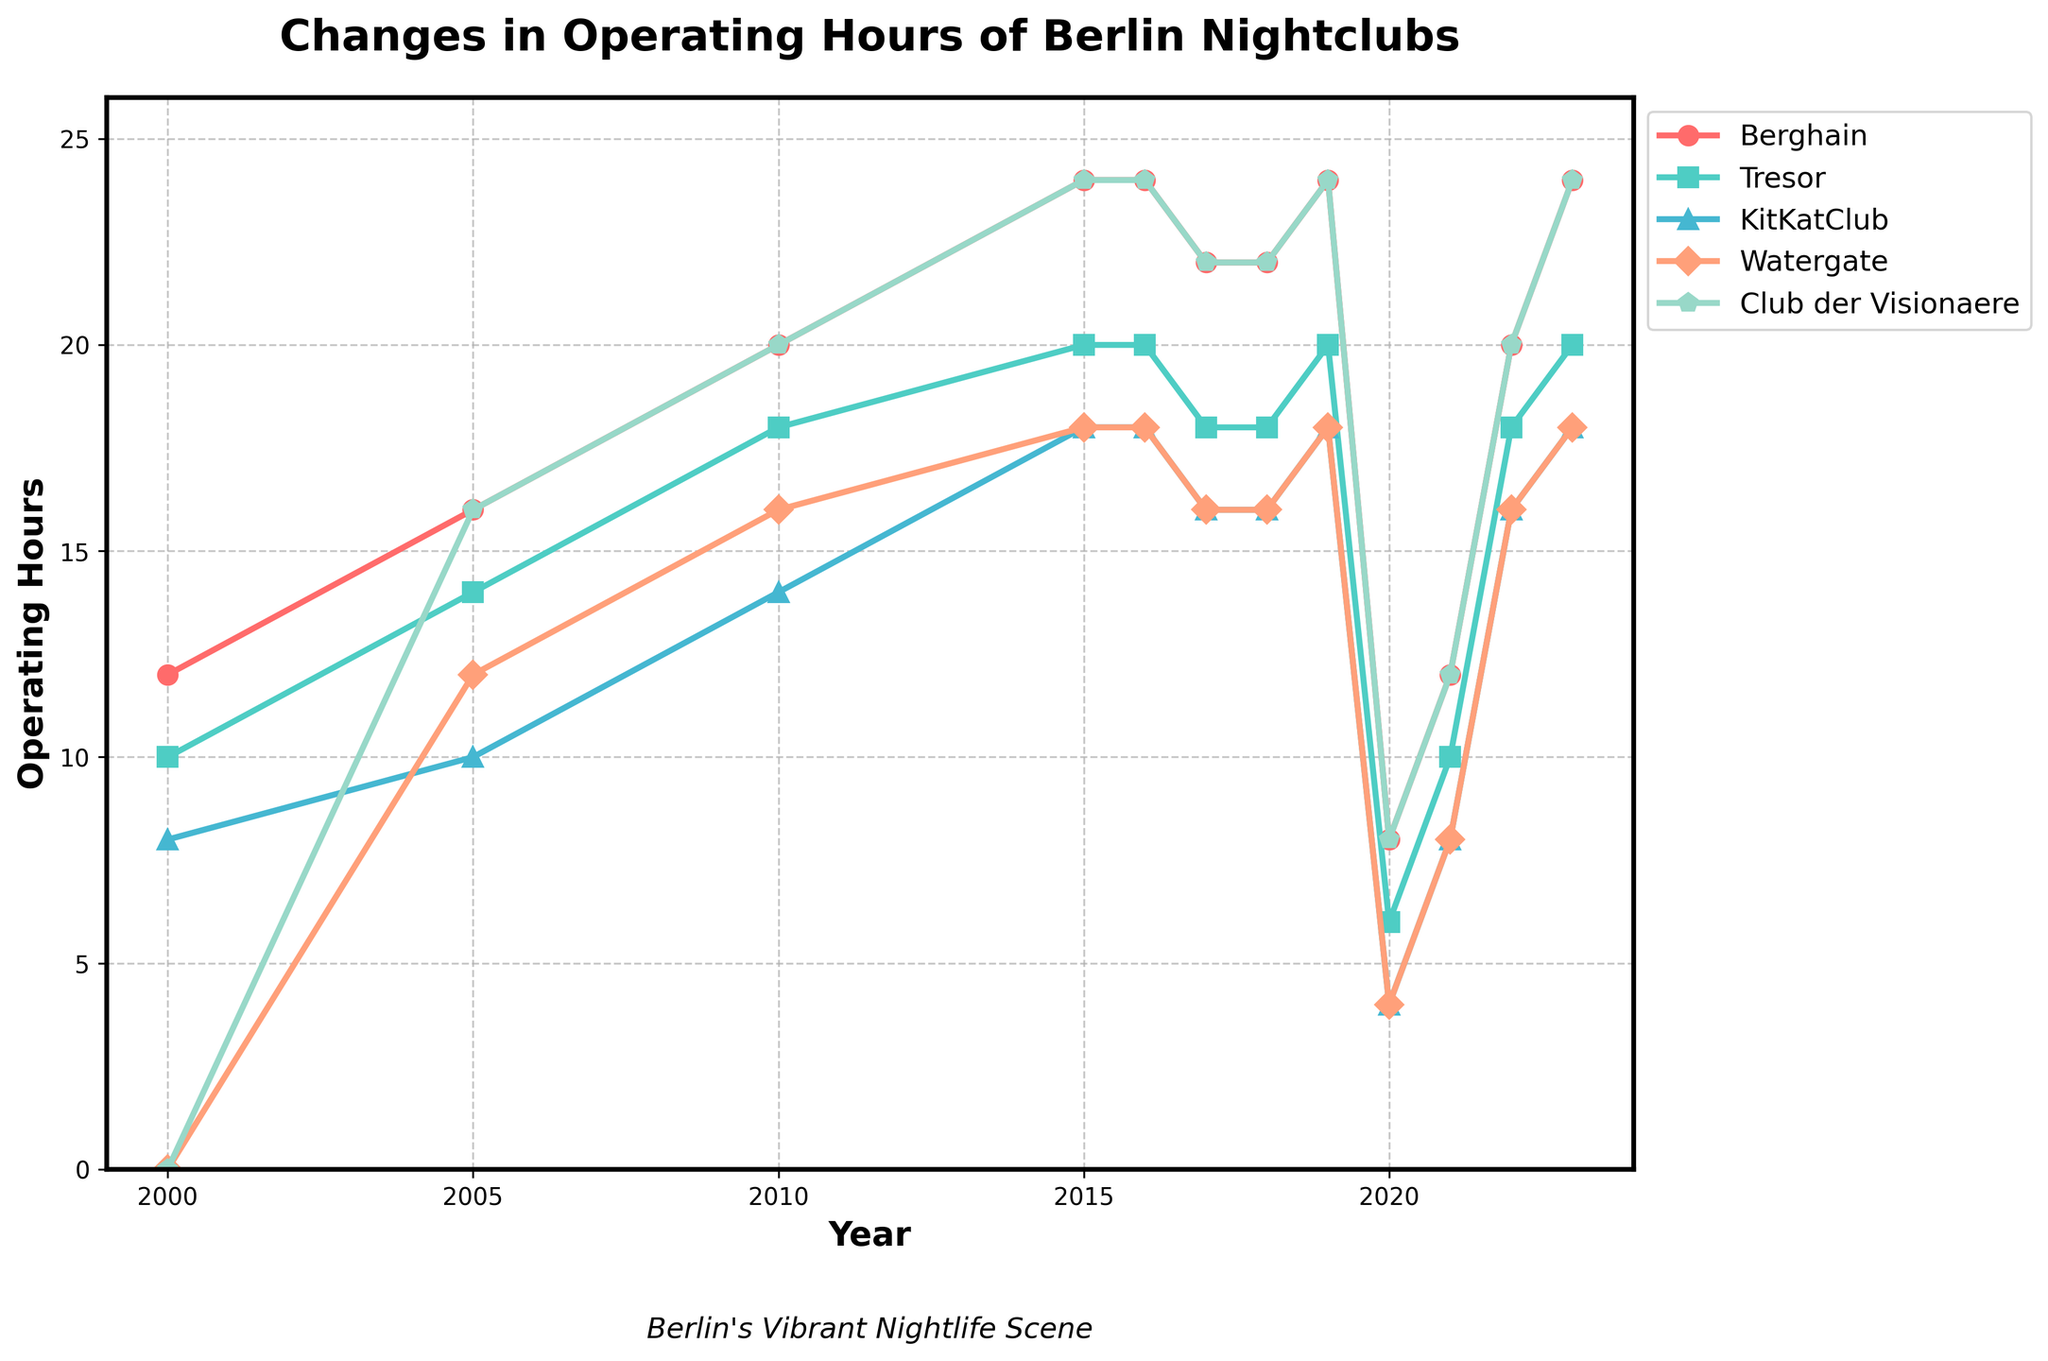Which nightclub had the highest operating hours in 2010? Look at the data points for the year 2010 and compare the values for each nightclub. Berghain has the highest operating hours with 20.
Answer: Berghain How did the operating hours of Tresor change from 2017 to 2018? Compare the data points for Tresor in 2017 (18 hours) and 2018 (18 hours). The operating hours remained the same.
Answer: Remained the same Which nightclub showed the largest decrease in operating hours between 2019 and 2020? Compare the operating hours of each nightclub between 2019 and 2020. Berghain decreased from 24 to 8 hours, which is the largest drop of 16 hours.
Answer: Berghain What was the average operating hours of KitKatClub in 2020 and 2023? Add the operating hours of KitKatClub in 2020 (4 hours) and 2023 (18 hours), then divide by 2. (4 + 18) / 2 = 11
Answer: 11 Which nightclub had the most stable operating hours from 2000 to 2023? By visually scanning the lines for each nightclub, Watergate appears the most stable, primarily remaining between 16 and 18 hours excluding the dip in 2020 and 2021.
Answer: Watergate What were the operating hours of Club der Visionaere in 2005, and how do they compare to its operating hours in 2015? Look at the data points for 2005 (16 hours) and 2015 (24 hours). Club der Visionaere's operating hours increased by 8 hours.
Answer: Increased by 8 hours Did Berghain or KitKatClub have a quicker recovery in operating hours after 2020? Compare the recovery in operating hours between 2020 and 2021 for Berghain (from 8 to 12 hours) and KitKatClub (from 4 to 8 hours). Berghain recovered by 4 hours, while KitKatClub recovered by 4 hours. Both had the same recovery rate.
Answer: Same recovery rate Which nightclub experienced a consistent increase in operating hours from 2000 to 2010? Examine the trend lines from 2000 to 2010. All clubs that existed in 2000 (Berghain, Tresor, KitKatClub) show consistent increase.
Answer: Berghain, Tresor, KitKatClub 